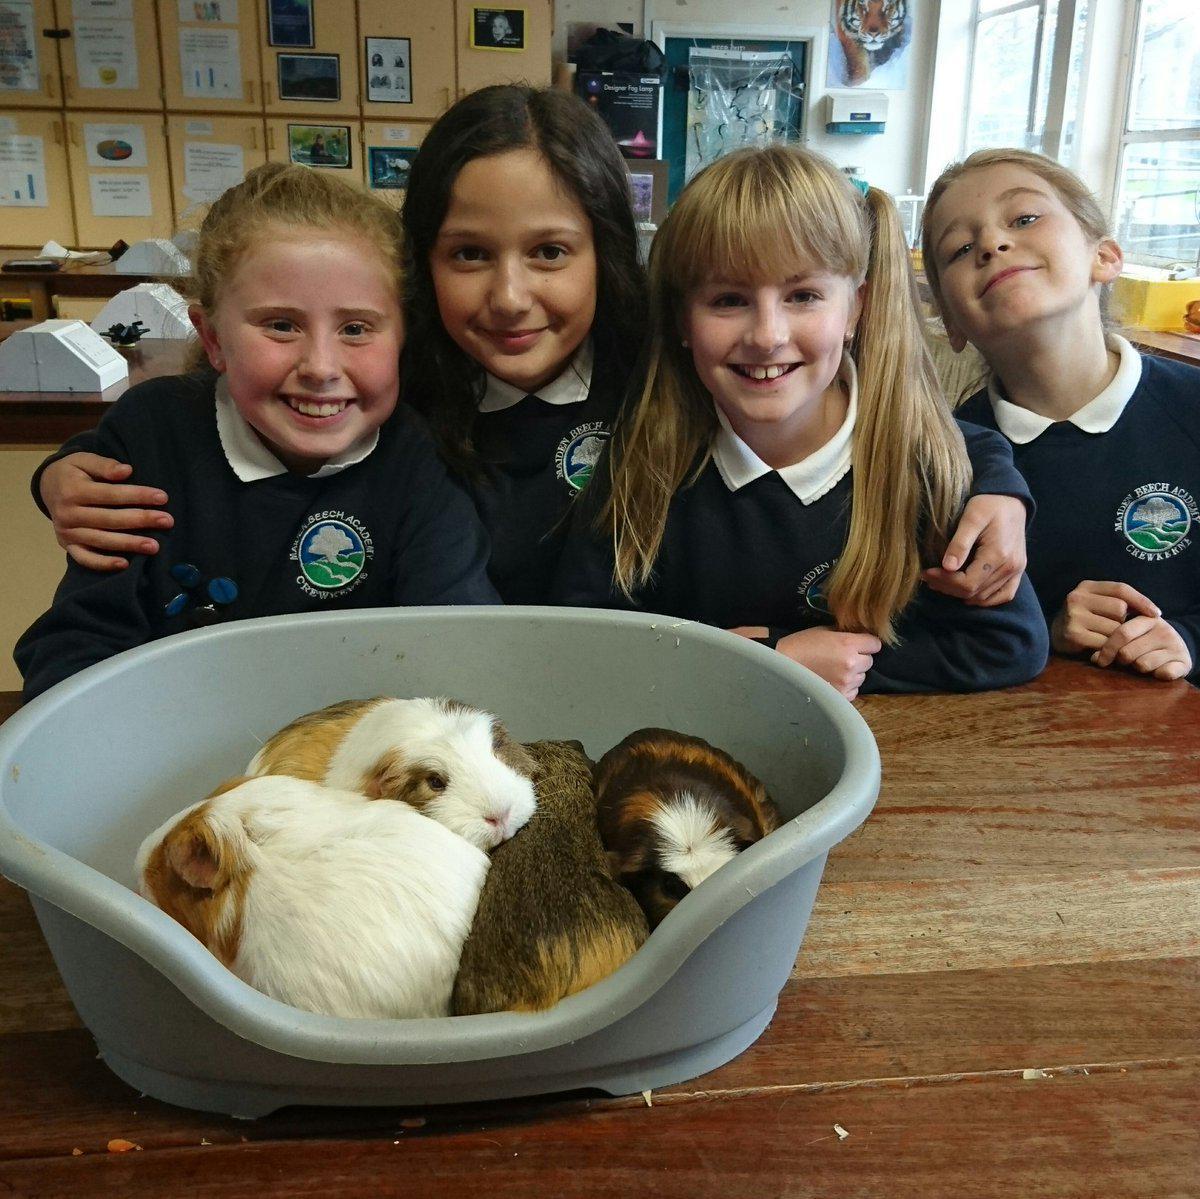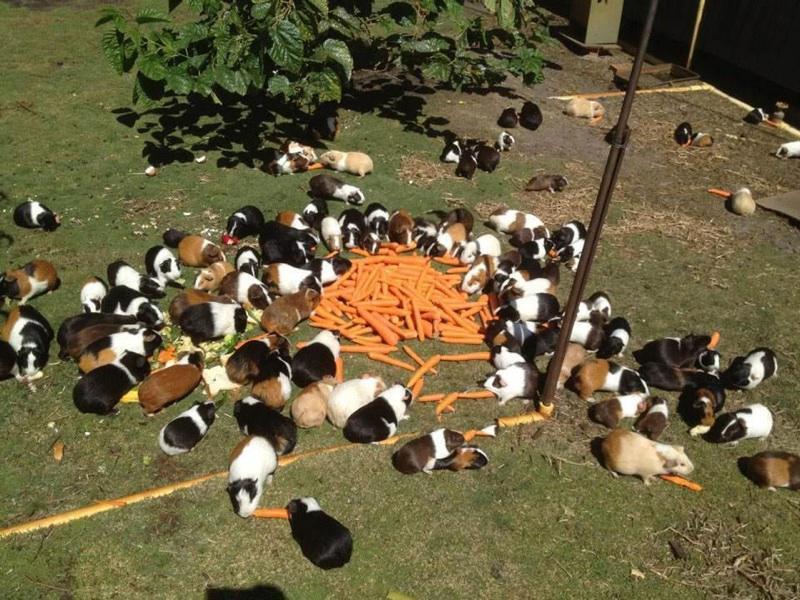The first image is the image on the left, the second image is the image on the right. Analyze the images presented: Is the assertion "One image includes no more than five hamsters." valid? Answer yes or no. Yes. The first image is the image on the left, the second image is the image on the right. Considering the images on both sides, is "The guinea pigs are eating in both images and are eating fresh green vegetation in one of the images." valid? Answer yes or no. No. 